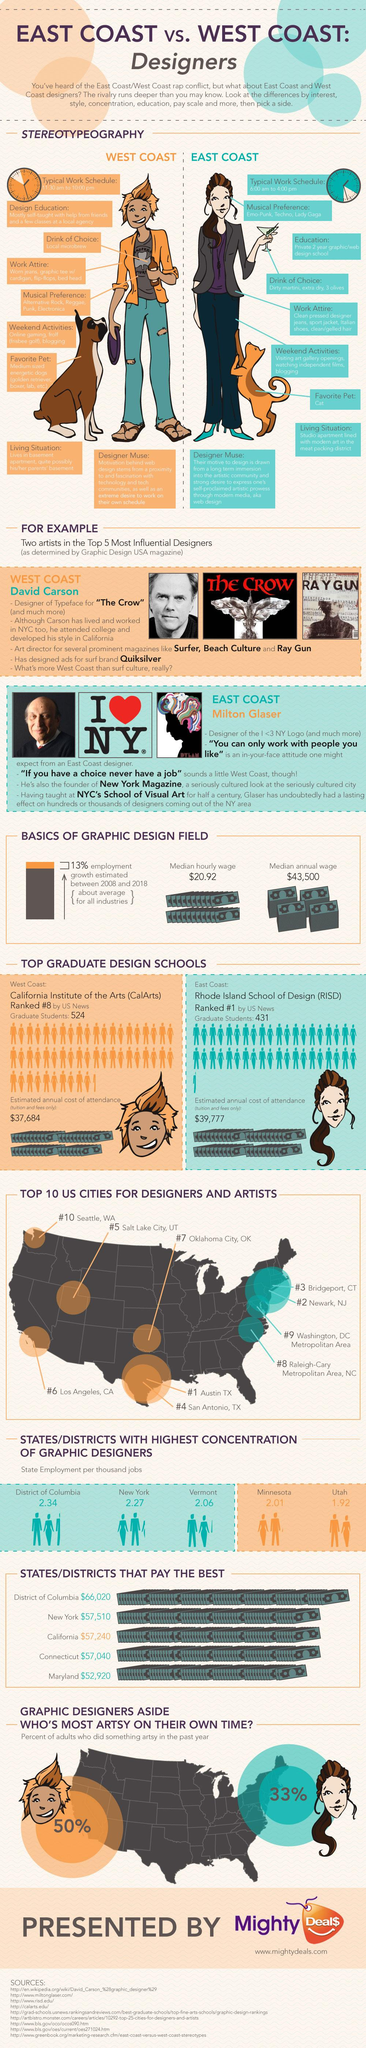Identify some key points in this picture. As of the state of Utah, there are 1.92 graphic designers employed. The median annual wage is approximately $43,500. The median hourly wage is $20.92. The calculated annual cost of attendance for the East Coast is 39,777. The Rhode Island School of Design is ranked first by US News. 